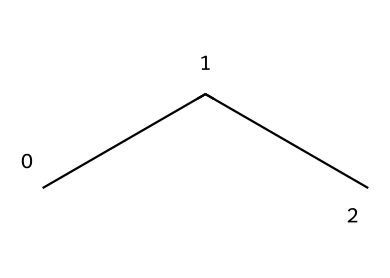What is the molecular formula for propane? Propane consists of three carbon atoms and eight hydrogen atoms. The molecular formula can be determined by counting the atoms visible in the structure.
Answer: C3H8 How many carbon atoms are in propane? By analyzing the structure represented by the SMILES, there are three 'C' characters, indicating three carbon atoms.
Answer: 3 How many hydrogen atoms are bonded to the propane structure? Each carbon atom in propane is bonded with enough hydrogen atoms to satisfy the tetravalent nature of carbon. Counting the hydrogen from the structure leads to a total of eight.
Answer: 8 What type of chemical is propane classified as? Propane is an alkane, characterized by single bonds between carbon atoms and having the general formula CnH2n+2, which applies here with three carbon atoms.
Answer: alkane What is one advantage of using propane as a refrigerant? Propane as a refrigerant is a natural refrigerant, leading to lower global warming potential compared to synthetic refrigerants. This property makes it advantageous for environmental considerations.
Answer: environmentally friendly What characteristic of propane allows it to serve as a refrigerant? The low boiling point of propane (about -42 degrees Celsius) makes it effective for heat absorption, which is essential for refrigeration processes.
Answer: low boiling point How does propane's molecular structure influence its flammability? The hydrocarbon structure of propane, combined with its gaseous state at room temperature, contributes to its high flammability compared to other refrigerants.
Answer: highly flammable 